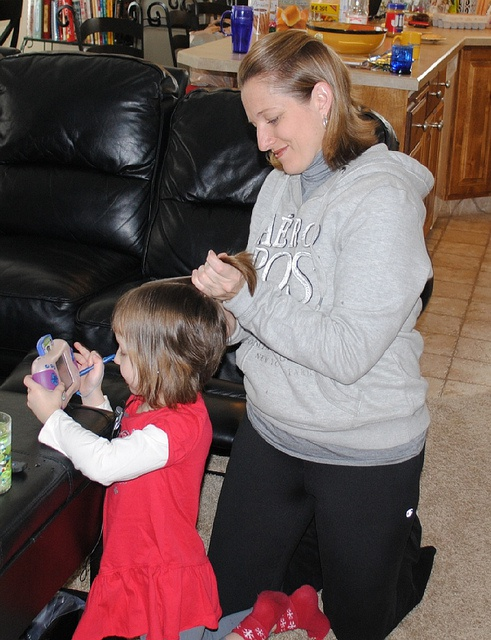Describe the objects in this image and their specific colors. I can see people in black, lightgray, darkgray, and tan tones, couch in black and gray tones, people in black, red, white, and gray tones, chair in black, gray, and maroon tones, and bowl in black, olive, orange, and tan tones in this image. 